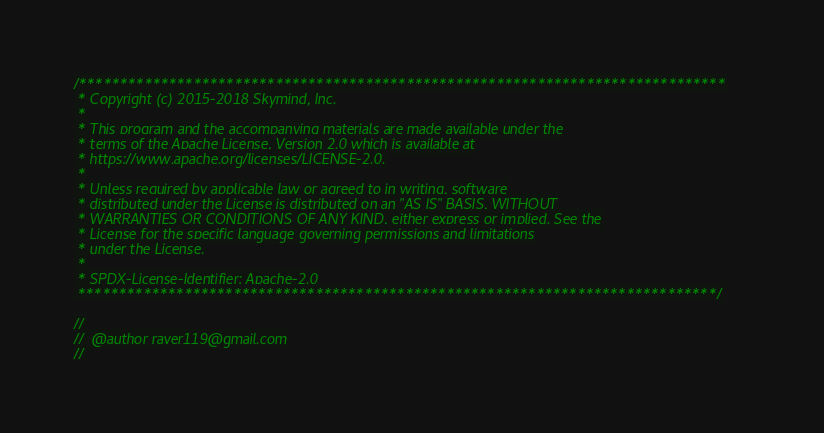Convert code to text. <code><loc_0><loc_0><loc_500><loc_500><_Cuda_>/*******************************************************************************
 * Copyright (c) 2015-2018 Skymind, Inc.
 *
 * This program and the accompanying materials are made available under the
 * terms of the Apache License, Version 2.0 which is available at
 * https://www.apache.org/licenses/LICENSE-2.0.
 *
 * Unless required by applicable law or agreed to in writing, software
 * distributed under the License is distributed on an "AS IS" BASIS, WITHOUT
 * WARRANTIES OR CONDITIONS OF ANY KIND, either express or implied. See the
 * License for the specific language governing permissions and limitations
 * under the License.
 *
 * SPDX-License-Identifier: Apache-2.0
 ******************************************************************************/

//
//  @author raver119@gmail.com
//
</code> 